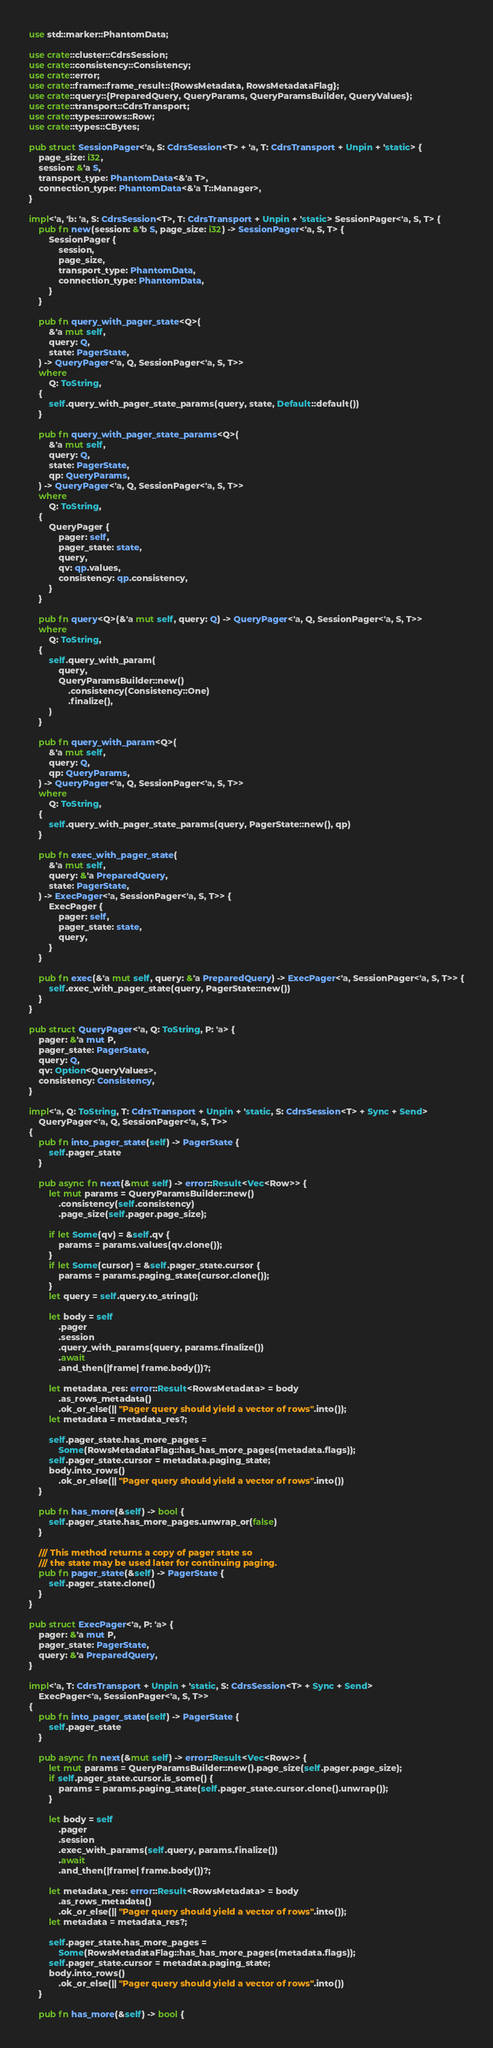<code> <loc_0><loc_0><loc_500><loc_500><_Rust_>use std::marker::PhantomData;

use crate::cluster::CdrsSession;
use crate::consistency::Consistency;
use crate::error;
use crate::frame::frame_result::{RowsMetadata, RowsMetadataFlag};
use crate::query::{PreparedQuery, QueryParams, QueryParamsBuilder, QueryValues};
use crate::transport::CdrsTransport;
use crate::types::rows::Row;
use crate::types::CBytes;

pub struct SessionPager<'a, S: CdrsSession<T> + 'a, T: CdrsTransport + Unpin + 'static> {
    page_size: i32,
    session: &'a S,
    transport_type: PhantomData<&'a T>,
    connection_type: PhantomData<&'a T::Manager>,
}

impl<'a, 'b: 'a, S: CdrsSession<T>, T: CdrsTransport + Unpin + 'static> SessionPager<'a, S, T> {
    pub fn new(session: &'b S, page_size: i32) -> SessionPager<'a, S, T> {
        SessionPager {
            session,
            page_size,
            transport_type: PhantomData,
            connection_type: PhantomData,
        }
    }

    pub fn query_with_pager_state<Q>(
        &'a mut self,
        query: Q,
        state: PagerState,
    ) -> QueryPager<'a, Q, SessionPager<'a, S, T>>
    where
        Q: ToString,
    {
        self.query_with_pager_state_params(query, state, Default::default())
    }

    pub fn query_with_pager_state_params<Q>(
        &'a mut self,
        query: Q,
        state: PagerState,
        qp: QueryParams,
    ) -> QueryPager<'a, Q, SessionPager<'a, S, T>>
    where
        Q: ToString,
    {
        QueryPager {
            pager: self,
            pager_state: state,
            query,
            qv: qp.values,
            consistency: qp.consistency,
        }
    }

    pub fn query<Q>(&'a mut self, query: Q) -> QueryPager<'a, Q, SessionPager<'a, S, T>>
    where
        Q: ToString,
    {
        self.query_with_param(
            query,
            QueryParamsBuilder::new()
                .consistency(Consistency::One)
                .finalize(),
        )
    }

    pub fn query_with_param<Q>(
        &'a mut self,
        query: Q,
        qp: QueryParams,
    ) -> QueryPager<'a, Q, SessionPager<'a, S, T>>
    where
        Q: ToString,
    {
        self.query_with_pager_state_params(query, PagerState::new(), qp)
    }

    pub fn exec_with_pager_state(
        &'a mut self,
        query: &'a PreparedQuery,
        state: PagerState,
    ) -> ExecPager<'a, SessionPager<'a, S, T>> {
        ExecPager {
            pager: self,
            pager_state: state,
            query,
        }
    }

    pub fn exec(&'a mut self, query: &'a PreparedQuery) -> ExecPager<'a, SessionPager<'a, S, T>> {
        self.exec_with_pager_state(query, PagerState::new())
    }
}

pub struct QueryPager<'a, Q: ToString, P: 'a> {
    pager: &'a mut P,
    pager_state: PagerState,
    query: Q,
    qv: Option<QueryValues>,
    consistency: Consistency,
}

impl<'a, Q: ToString, T: CdrsTransport + Unpin + 'static, S: CdrsSession<T> + Sync + Send>
    QueryPager<'a, Q, SessionPager<'a, S, T>>
{
    pub fn into_pager_state(self) -> PagerState {
        self.pager_state
    }

    pub async fn next(&mut self) -> error::Result<Vec<Row>> {
        let mut params = QueryParamsBuilder::new()
            .consistency(self.consistency)
            .page_size(self.pager.page_size);

        if let Some(qv) = &self.qv {
            params = params.values(qv.clone());
        }
        if let Some(cursor) = &self.pager_state.cursor {
            params = params.paging_state(cursor.clone());
        }
        let query = self.query.to_string();

        let body = self
            .pager
            .session
            .query_with_params(query, params.finalize())
            .await
            .and_then(|frame| frame.body())?;

        let metadata_res: error::Result<RowsMetadata> = body
            .as_rows_metadata()
            .ok_or_else(|| "Pager query should yield a vector of rows".into());
        let metadata = metadata_res?;

        self.pager_state.has_more_pages =
            Some(RowsMetadataFlag::has_has_more_pages(metadata.flags));
        self.pager_state.cursor = metadata.paging_state;
        body.into_rows()
            .ok_or_else(|| "Pager query should yield a vector of rows".into())
    }

    pub fn has_more(&self) -> bool {
        self.pager_state.has_more_pages.unwrap_or(false)
    }

    /// This method returns a copy of pager state so
    /// the state may be used later for continuing paging.
    pub fn pager_state(&self) -> PagerState {
        self.pager_state.clone()
    }
}

pub struct ExecPager<'a, P: 'a> {
    pager: &'a mut P,
    pager_state: PagerState,
    query: &'a PreparedQuery,
}

impl<'a, T: CdrsTransport + Unpin + 'static, S: CdrsSession<T> + Sync + Send>
    ExecPager<'a, SessionPager<'a, S, T>>
{
    pub fn into_pager_state(self) -> PagerState {
        self.pager_state
    }

    pub async fn next(&mut self) -> error::Result<Vec<Row>> {
        let mut params = QueryParamsBuilder::new().page_size(self.pager.page_size);
        if self.pager_state.cursor.is_some() {
            params = params.paging_state(self.pager_state.cursor.clone().unwrap());
        }

        let body = self
            .pager
            .session
            .exec_with_params(self.query, params.finalize())
            .await
            .and_then(|frame| frame.body())?;

        let metadata_res: error::Result<RowsMetadata> = body
            .as_rows_metadata()
            .ok_or_else(|| "Pager query should yield a vector of rows".into());
        let metadata = metadata_res?;

        self.pager_state.has_more_pages =
            Some(RowsMetadataFlag::has_has_more_pages(metadata.flags));
        self.pager_state.cursor = metadata.paging_state;
        body.into_rows()
            .ok_or_else(|| "Pager query should yield a vector of rows".into())
    }

    pub fn has_more(&self) -> bool {</code> 